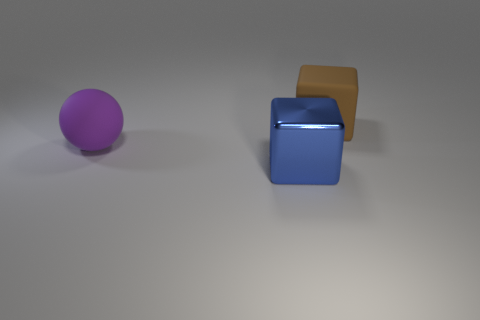Subtract all red cubes. Subtract all brown spheres. How many cubes are left? 2 Add 1 large purple rubber balls. How many objects exist? 4 Subtract all spheres. How many objects are left? 2 Subtract all big shiny things. Subtract all rubber things. How many objects are left? 0 Add 2 purple things. How many purple things are left? 3 Add 3 blue matte things. How many blue matte things exist? 3 Subtract 0 green cylinders. How many objects are left? 3 